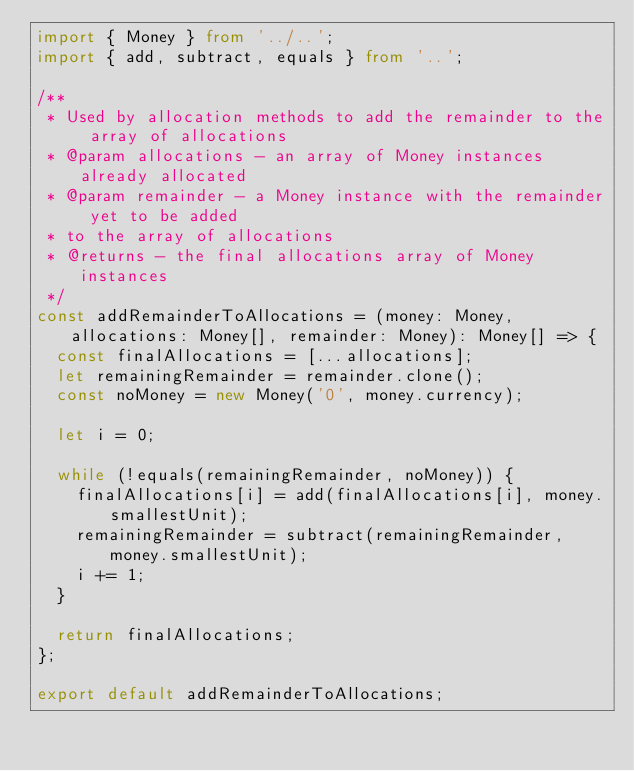Convert code to text. <code><loc_0><loc_0><loc_500><loc_500><_TypeScript_>import { Money } from '../..';
import { add, subtract, equals } from '..';

/**
 * Used by allocation methods to add the remainder to the array of allocations
 * @param allocations - an array of Money instances already allocated
 * @param remainder - a Money instance with the remainder yet to be added
 * to the array of allocations
 * @returns - the final allocations array of Money instances
 */
const addRemainderToAllocations = (money: Money, allocations: Money[], remainder: Money): Money[] => {
  const finalAllocations = [...allocations];
  let remainingRemainder = remainder.clone();
  const noMoney = new Money('0', money.currency);

  let i = 0;

  while (!equals(remainingRemainder, noMoney)) {
    finalAllocations[i] = add(finalAllocations[i], money.smallestUnit);
    remainingRemainder = subtract(remainingRemainder, money.smallestUnit);
    i += 1;
  }

  return finalAllocations;
};

export default addRemainderToAllocations;
</code> 